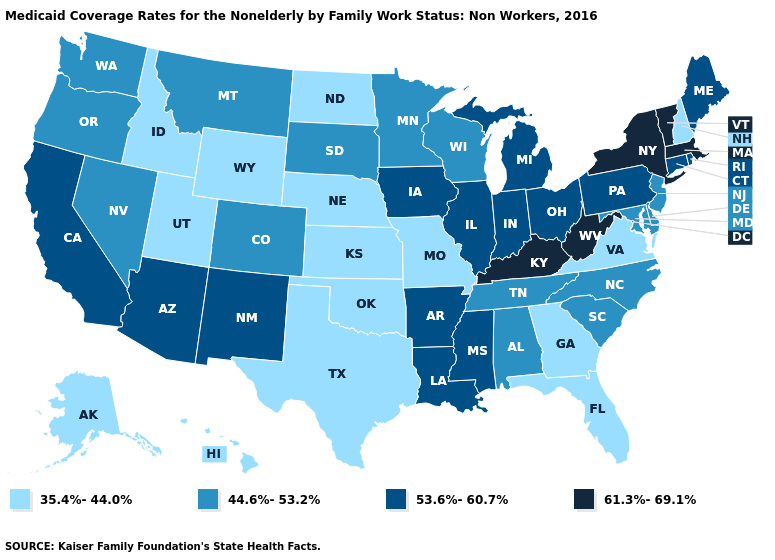What is the highest value in the USA?
Be succinct. 61.3%-69.1%. Name the states that have a value in the range 35.4%-44.0%?
Quick response, please. Alaska, Florida, Georgia, Hawaii, Idaho, Kansas, Missouri, Nebraska, New Hampshire, North Dakota, Oklahoma, Texas, Utah, Virginia, Wyoming. Which states have the lowest value in the USA?
Be succinct. Alaska, Florida, Georgia, Hawaii, Idaho, Kansas, Missouri, Nebraska, New Hampshire, North Dakota, Oklahoma, Texas, Utah, Virginia, Wyoming. What is the value of Pennsylvania?
Be succinct. 53.6%-60.7%. Which states hav the highest value in the MidWest?
Quick response, please. Illinois, Indiana, Iowa, Michigan, Ohio. Does Missouri have the lowest value in the MidWest?
Answer briefly. Yes. What is the highest value in states that border Mississippi?
Answer briefly. 53.6%-60.7%. Among the states that border South Carolina , which have the lowest value?
Give a very brief answer. Georgia. Among the states that border Montana , does South Dakota have the lowest value?
Answer briefly. No. Name the states that have a value in the range 44.6%-53.2%?
Write a very short answer. Alabama, Colorado, Delaware, Maryland, Minnesota, Montana, Nevada, New Jersey, North Carolina, Oregon, South Carolina, South Dakota, Tennessee, Washington, Wisconsin. Which states have the lowest value in the West?
Concise answer only. Alaska, Hawaii, Idaho, Utah, Wyoming. Does Rhode Island have the same value as North Carolina?
Short answer required. No. Name the states that have a value in the range 53.6%-60.7%?
Quick response, please. Arizona, Arkansas, California, Connecticut, Illinois, Indiana, Iowa, Louisiana, Maine, Michigan, Mississippi, New Mexico, Ohio, Pennsylvania, Rhode Island. Does Washington have the lowest value in the USA?
Quick response, please. No. 